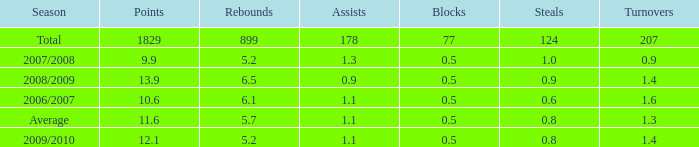How many blocks are there when the rebounds are fewer than 5.2? 0.0. 